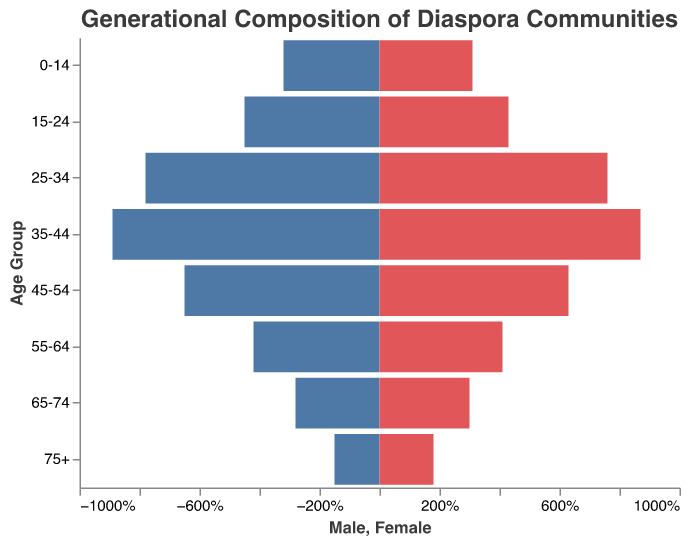What is the title of the figure? The title is located at the top center of the figure and is displayed in a larger font size than the rest of the text.
Answer: Generational Composition of Diaspora Communities What age group has the highest male population percentage? To find this, compare the lengths of the bars for male populations in different age groups. The longest bar represents the highest percentage.
Answer: 35-44 Which age group has a higher proportion of females than males? Look for age groups where the bar for females is longer than the bar for males.
Answer: 65-74 and 75+ What is the percentage difference between males and females in the age group 25-34? Find the male and female percentages for the age group 25-34 and then subtract the smaller percentage from the larger one: 7.8% (Male) - 7.6% (Female) = 0.2%.
Answer: 0.2% How does the population percentage of males aged 45-54 compare to males aged 15-24? Compare the lengths of the bars for these two age groups.
Answer: Lower in 45-54 What is the total percentage of the population for females in the age groups 55-64 and 75+ combined? Add the percentages for the female populations in these two age groups: 4.1% (55-64) + 1.8% (75+) = 5.9%.
Answer: 5.9% Which age group has the smallest combined population percentage for both males and females? Calculate the combined percentages for each age group and find the smallest sum. The smallest combined percentage is: 1.5% (Male) + 1.8% (Female) = 3.3% in the 75+ age group.
Answer: 75+ Which age group shows the most significant difference between male and female population percentages? Calculate the differences for each age group. The largest difference is in the 75+ age group: 1.8% (Female) - 1.5% (Male) = 0.3%.
Answer: 75+ What is the gender ratio (Male to Female) for the age group 35-44? Find the proportions of males and females in the age group 35-44 and form the ratio: 8.9 (Male) to 8.7 (Female) = 8.9:8.7.
Answer: 8.9:8.7 